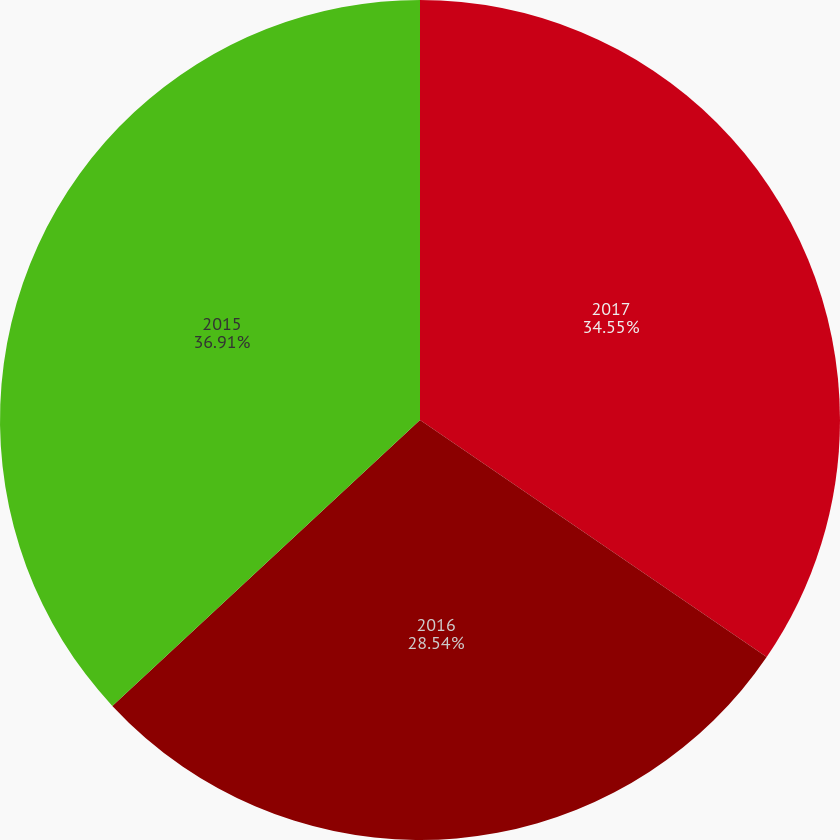Convert chart to OTSL. <chart><loc_0><loc_0><loc_500><loc_500><pie_chart><fcel>2017<fcel>2016<fcel>2015<nl><fcel>34.55%<fcel>28.54%<fcel>36.92%<nl></chart> 